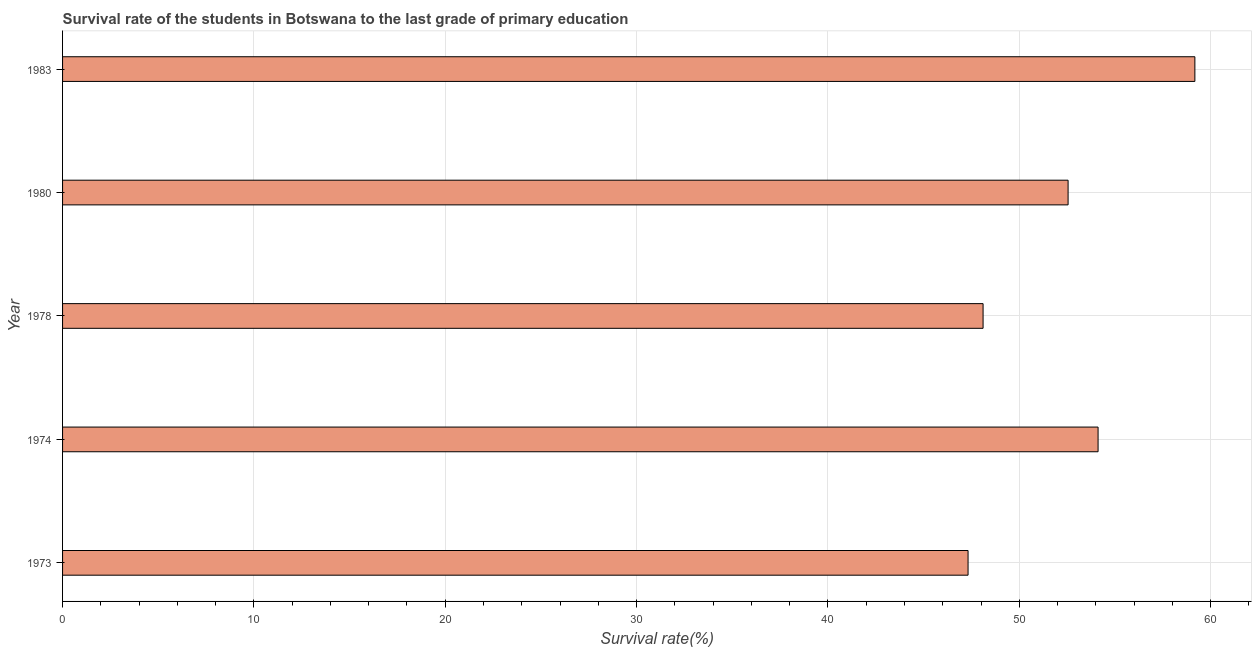Does the graph contain any zero values?
Give a very brief answer. No. What is the title of the graph?
Your response must be concise. Survival rate of the students in Botswana to the last grade of primary education. What is the label or title of the X-axis?
Your response must be concise. Survival rate(%). What is the survival rate in primary education in 1974?
Your response must be concise. 54.12. Across all years, what is the maximum survival rate in primary education?
Give a very brief answer. 59.18. Across all years, what is the minimum survival rate in primary education?
Your answer should be very brief. 47.32. In which year was the survival rate in primary education maximum?
Your answer should be compact. 1983. What is the sum of the survival rate in primary education?
Your response must be concise. 261.27. What is the difference between the survival rate in primary education in 1973 and 1978?
Your response must be concise. -0.79. What is the average survival rate in primary education per year?
Make the answer very short. 52.26. What is the median survival rate in primary education?
Provide a short and direct response. 52.55. In how many years, is the survival rate in primary education greater than 10 %?
Your response must be concise. 5. Do a majority of the years between 1980 and 1978 (inclusive) have survival rate in primary education greater than 52 %?
Offer a very short reply. No. What is the ratio of the survival rate in primary education in 1973 to that in 1983?
Your response must be concise. 0.8. Is the survival rate in primary education in 1973 less than that in 1980?
Make the answer very short. Yes. What is the difference between the highest and the second highest survival rate in primary education?
Your response must be concise. 5.06. What is the difference between the highest and the lowest survival rate in primary education?
Ensure brevity in your answer.  11.85. How many bars are there?
Your answer should be very brief. 5. Are all the bars in the graph horizontal?
Provide a short and direct response. Yes. What is the difference between two consecutive major ticks on the X-axis?
Ensure brevity in your answer.  10. What is the Survival rate(%) of 1973?
Make the answer very short. 47.32. What is the Survival rate(%) of 1974?
Keep it short and to the point. 54.12. What is the Survival rate(%) of 1978?
Offer a very short reply. 48.11. What is the Survival rate(%) in 1980?
Give a very brief answer. 52.55. What is the Survival rate(%) in 1983?
Your answer should be very brief. 59.18. What is the difference between the Survival rate(%) in 1973 and 1974?
Make the answer very short. -6.79. What is the difference between the Survival rate(%) in 1973 and 1978?
Keep it short and to the point. -0.79. What is the difference between the Survival rate(%) in 1973 and 1980?
Provide a short and direct response. -5.23. What is the difference between the Survival rate(%) in 1973 and 1983?
Make the answer very short. -11.85. What is the difference between the Survival rate(%) in 1974 and 1978?
Give a very brief answer. 6.01. What is the difference between the Survival rate(%) in 1974 and 1980?
Your response must be concise. 1.57. What is the difference between the Survival rate(%) in 1974 and 1983?
Give a very brief answer. -5.06. What is the difference between the Survival rate(%) in 1978 and 1980?
Your response must be concise. -4.44. What is the difference between the Survival rate(%) in 1978 and 1983?
Your answer should be compact. -11.07. What is the difference between the Survival rate(%) in 1980 and 1983?
Provide a succinct answer. -6.63. What is the ratio of the Survival rate(%) in 1973 to that in 1974?
Provide a succinct answer. 0.87. What is the ratio of the Survival rate(%) in 1973 to that in 1978?
Make the answer very short. 0.98. What is the ratio of the Survival rate(%) in 1973 to that in 1980?
Give a very brief answer. 0.9. What is the ratio of the Survival rate(%) in 1973 to that in 1983?
Your response must be concise. 0.8. What is the ratio of the Survival rate(%) in 1974 to that in 1983?
Make the answer very short. 0.92. What is the ratio of the Survival rate(%) in 1978 to that in 1980?
Your answer should be very brief. 0.92. What is the ratio of the Survival rate(%) in 1978 to that in 1983?
Keep it short and to the point. 0.81. What is the ratio of the Survival rate(%) in 1980 to that in 1983?
Offer a very short reply. 0.89. 